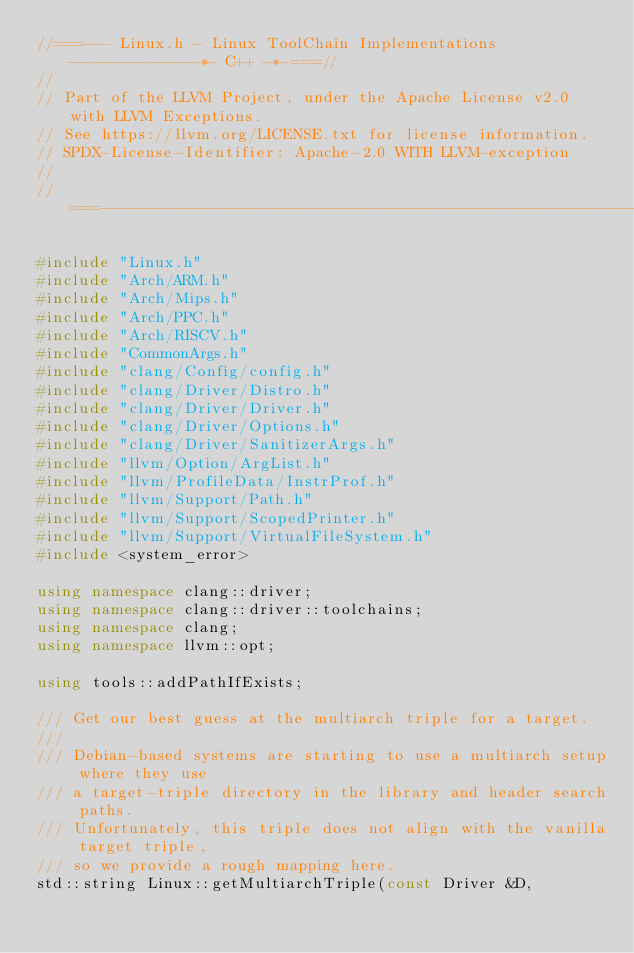Convert code to text. <code><loc_0><loc_0><loc_500><loc_500><_C++_>//===--- Linux.h - Linux ToolChain Implementations --------------*- C++ -*-===//
//
// Part of the LLVM Project, under the Apache License v2.0 with LLVM Exceptions.
// See https://llvm.org/LICENSE.txt for license information.
// SPDX-License-Identifier: Apache-2.0 WITH LLVM-exception
//
//===----------------------------------------------------------------------===//

#include "Linux.h"
#include "Arch/ARM.h"
#include "Arch/Mips.h"
#include "Arch/PPC.h"
#include "Arch/RISCV.h"
#include "CommonArgs.h"
#include "clang/Config/config.h"
#include "clang/Driver/Distro.h"
#include "clang/Driver/Driver.h"
#include "clang/Driver/Options.h"
#include "clang/Driver/SanitizerArgs.h"
#include "llvm/Option/ArgList.h"
#include "llvm/ProfileData/InstrProf.h"
#include "llvm/Support/Path.h"
#include "llvm/Support/ScopedPrinter.h"
#include "llvm/Support/VirtualFileSystem.h"
#include <system_error>

using namespace clang::driver;
using namespace clang::driver::toolchains;
using namespace clang;
using namespace llvm::opt;

using tools::addPathIfExists;

/// Get our best guess at the multiarch triple for a target.
///
/// Debian-based systems are starting to use a multiarch setup where they use
/// a target-triple directory in the library and header search paths.
/// Unfortunately, this triple does not align with the vanilla target triple,
/// so we provide a rough mapping here.
std::string Linux::getMultiarchTriple(const Driver &D,</code> 